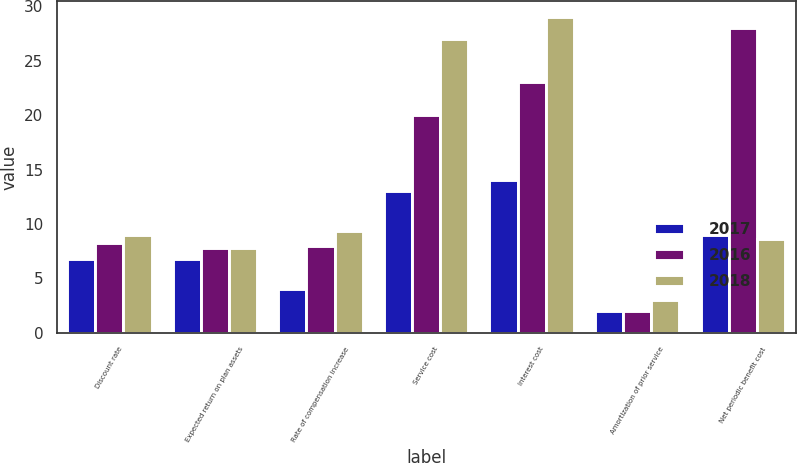Convert chart to OTSL. <chart><loc_0><loc_0><loc_500><loc_500><stacked_bar_chart><ecel><fcel>Discount rate<fcel>Expected return on plan assets<fcel>Rate of compensation increase<fcel>Service cost<fcel>Interest cost<fcel>Amortization of prior service<fcel>Net periodic benefit cost<nl><fcel>2017<fcel>6.75<fcel>6.75<fcel>4<fcel>13<fcel>14<fcel>2<fcel>9<nl><fcel>2016<fcel>8.25<fcel>7.75<fcel>8<fcel>20<fcel>23<fcel>2<fcel>28<nl><fcel>2018<fcel>9<fcel>7.75<fcel>9.4<fcel>27<fcel>29<fcel>3<fcel>8.625<nl></chart> 